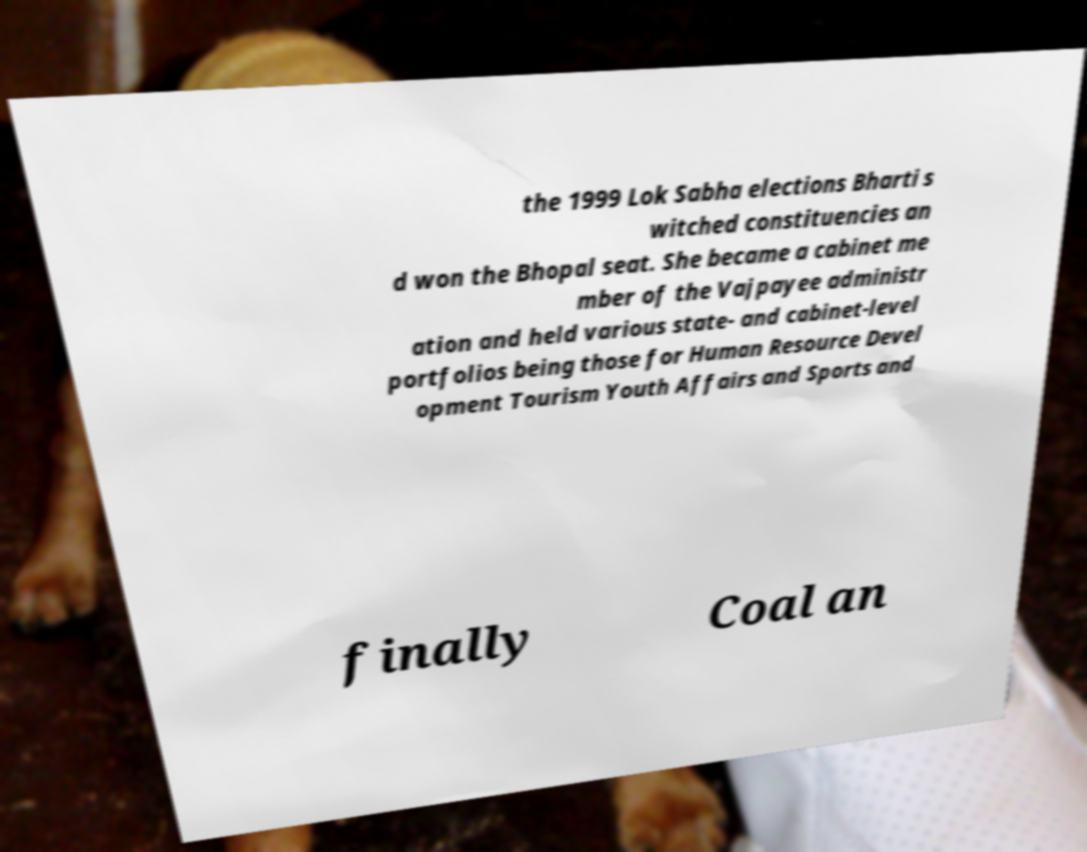I need the written content from this picture converted into text. Can you do that? the 1999 Lok Sabha elections Bharti s witched constituencies an d won the Bhopal seat. She became a cabinet me mber of the Vajpayee administr ation and held various state- and cabinet-level portfolios being those for Human Resource Devel opment Tourism Youth Affairs and Sports and finally Coal an 